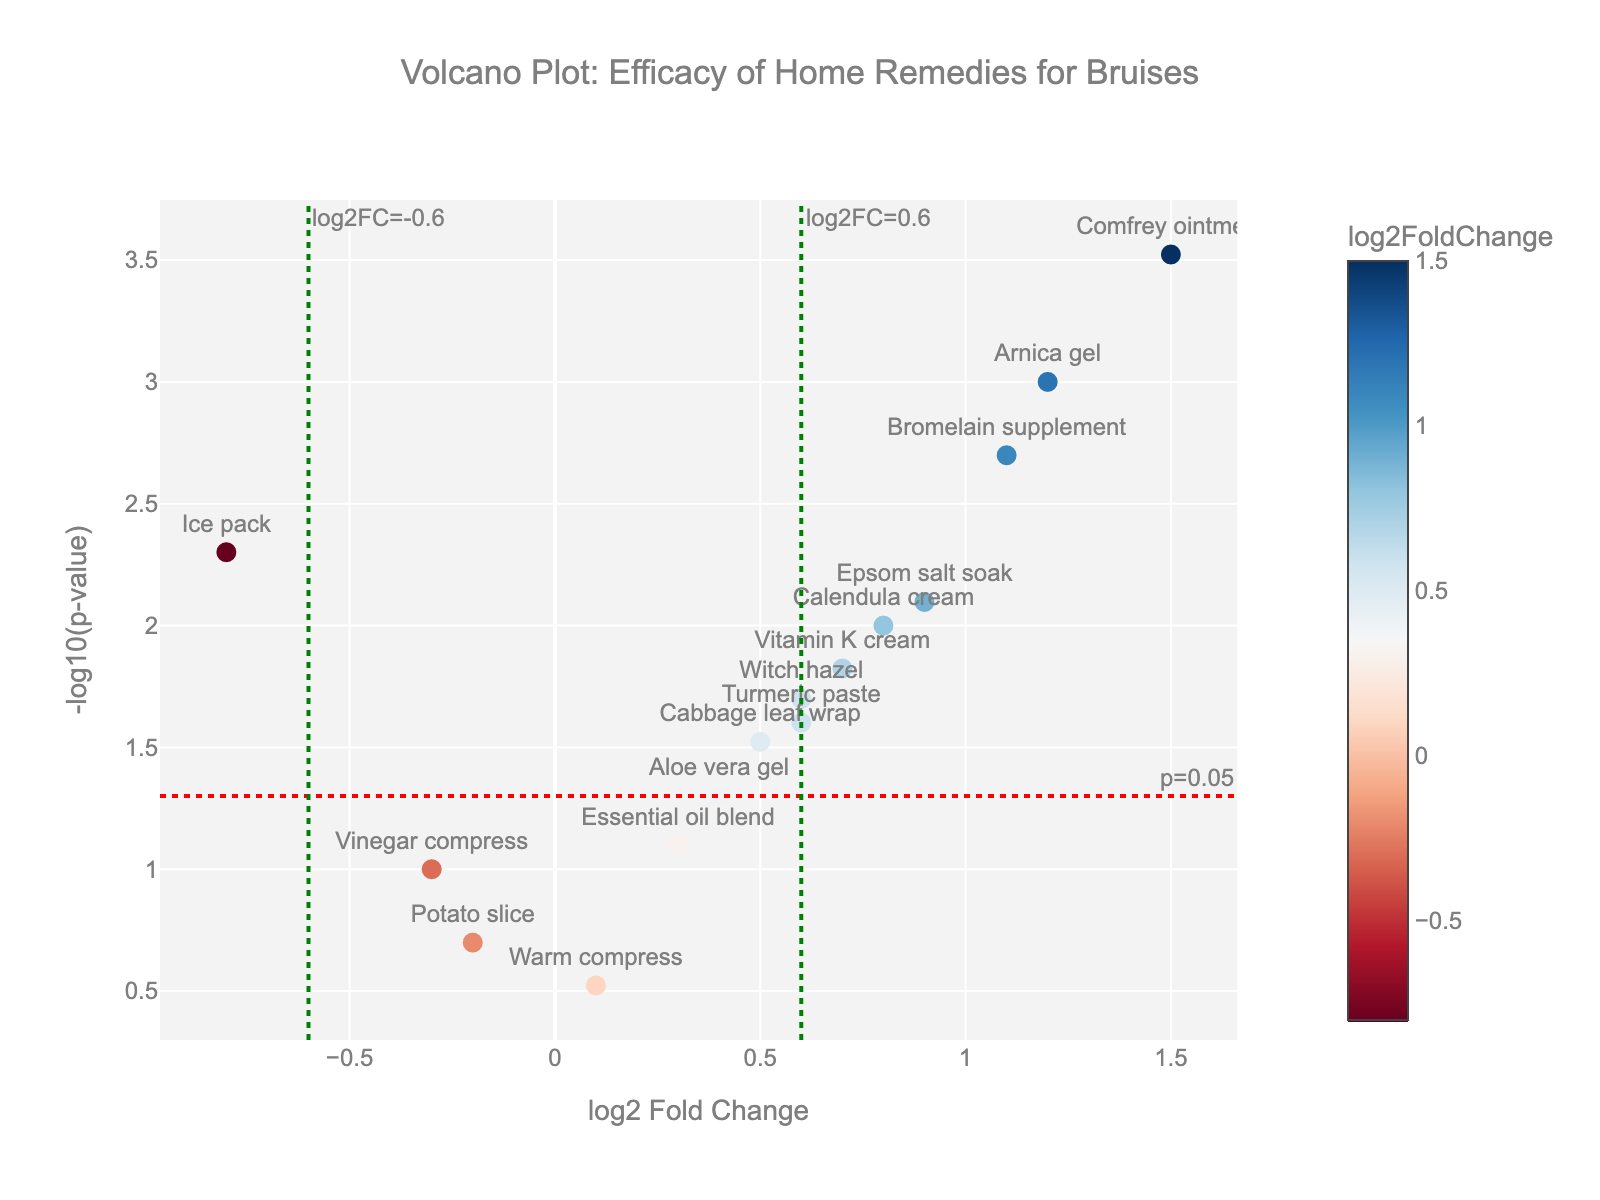how many home remedies are displayed in the plot? By counting the number of data points or labels shown in the figure, we can see that there are 15 distinct home remedies displayed.
Answer: 15 Which remedy has the highest statistical significance for effectiveness? The remedy with the highest statistical significance will have the highest -log10(p-value), represented by the highest point on the y-axis. Comfrey ointment is the highest.
Answer: Comfrey ointment Which remedies are downregulated based on log2FoldChange? Downregulated remedies will have a negative log2FoldChange value. Ice pack, Vinegar compress, and Potato slice all have negative log2FoldChange values.
Answer: Ice pack, Vinegar compress, Potato slice Which remedy is closest to the log2FoldChange threshold of -0.6? The remedy closest to the threshold line at log2FoldChange=-0.6 will have a log2FoldChange value near -0.6. The Ice pack is closest but slightly higher.
Answer: Ice pack Are there any remedies that are not statistically significant at p=0.05? Remedies that are not statistically significant will be below the horizontal threshold line of -log10(p-value) = 1.3. Remedies such as Vinegar compress, Essential oil blend, Potato slice, and Warm compress are below this line.
Answer: Vinegar compress, Essential oil blend, Potato slice, Warm compress Which remedy has the largest positive log2FoldChange? The log2FoldChange is represented on the x-axis, and the largest positive value will be the point farthest to the right. Comfrey ointment has the largest positive value.
Answer: Comfrey ointment What is the log2FoldChange value for Arnica gel, and is it statistically significant? Arnica gel has a log2FoldChange of 1.2 and a p-value below 0.05, making it statistically significant.
Answer: log2FoldChange: 1.2, Yes Compare the statistical significance of Epsom salt soak and Witch hazel. Which is more significant? Epsom salt soak has a -log10(p-value) higher than Witch hazel, indicating it is more statistically significant.
Answer: Epsom salt soak List the remedies with a log2FoldChange greater than 1.0. By checking the x-axis, remedies with a log2FoldChange greater than 1.0 include Arnica gel, Comfrey ointment, and Bromelain supplement.
Answer: Arnica gel, Comfrey ointment, Bromelain supplement What are the treatments that have both a positive log2FoldChange and a p-value less than 0.05? Positive log2FoldChange values are to the right of the vertical threshold line at 0, and p-values less than 0.05 are above the horizontal threshold line at -log10(0.05). Treatments include Arnica gel, Epsom salt soak, Comfrey ointment, Witch hazel, Vitamin K cream, Calendula cream, and Bromelain supplement.
Answer: Arnica gel, Epsom salt soak, Comfrey ointment, Witch hazel, Vitamin K cream, Calendula cream, Bromelain supplement 